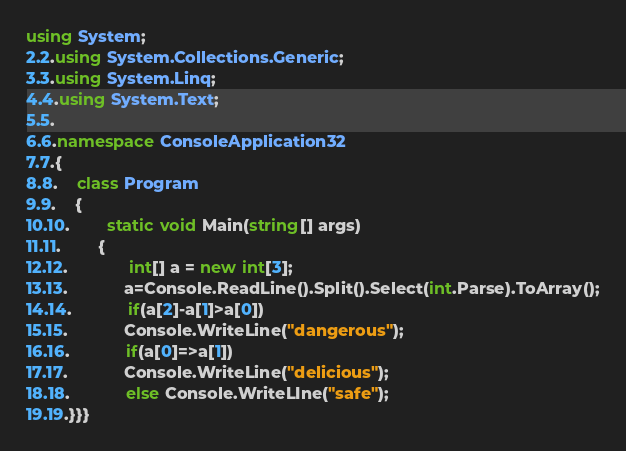<code> <loc_0><loc_0><loc_500><loc_500><_C#_>using System;
2.2.using System.Collections.Generic;
3.3.using System.Linq;
4.4.using System.Text;
5.5. 
6.6.namespace ConsoleApplication32
7.7.{
8.8.    class Program
9.9.    {
10.10.        static void Main(string[] args)
11.11.        {
12.12.             int[] a = new int[3];
13.13.            a=Console.ReadLine().Split().Select(int.Parse).ToArray();
14.14.            if(a[2]-a[1]>a[0])
15.15.            Console.WriteLine("dangerous");
16.16.            if(a[0]=>a[1])
17.17.            Console.WriteLine("delicious");
18.18.            else Console.WriteLIne("safe");
19.19.}}}
</code> 